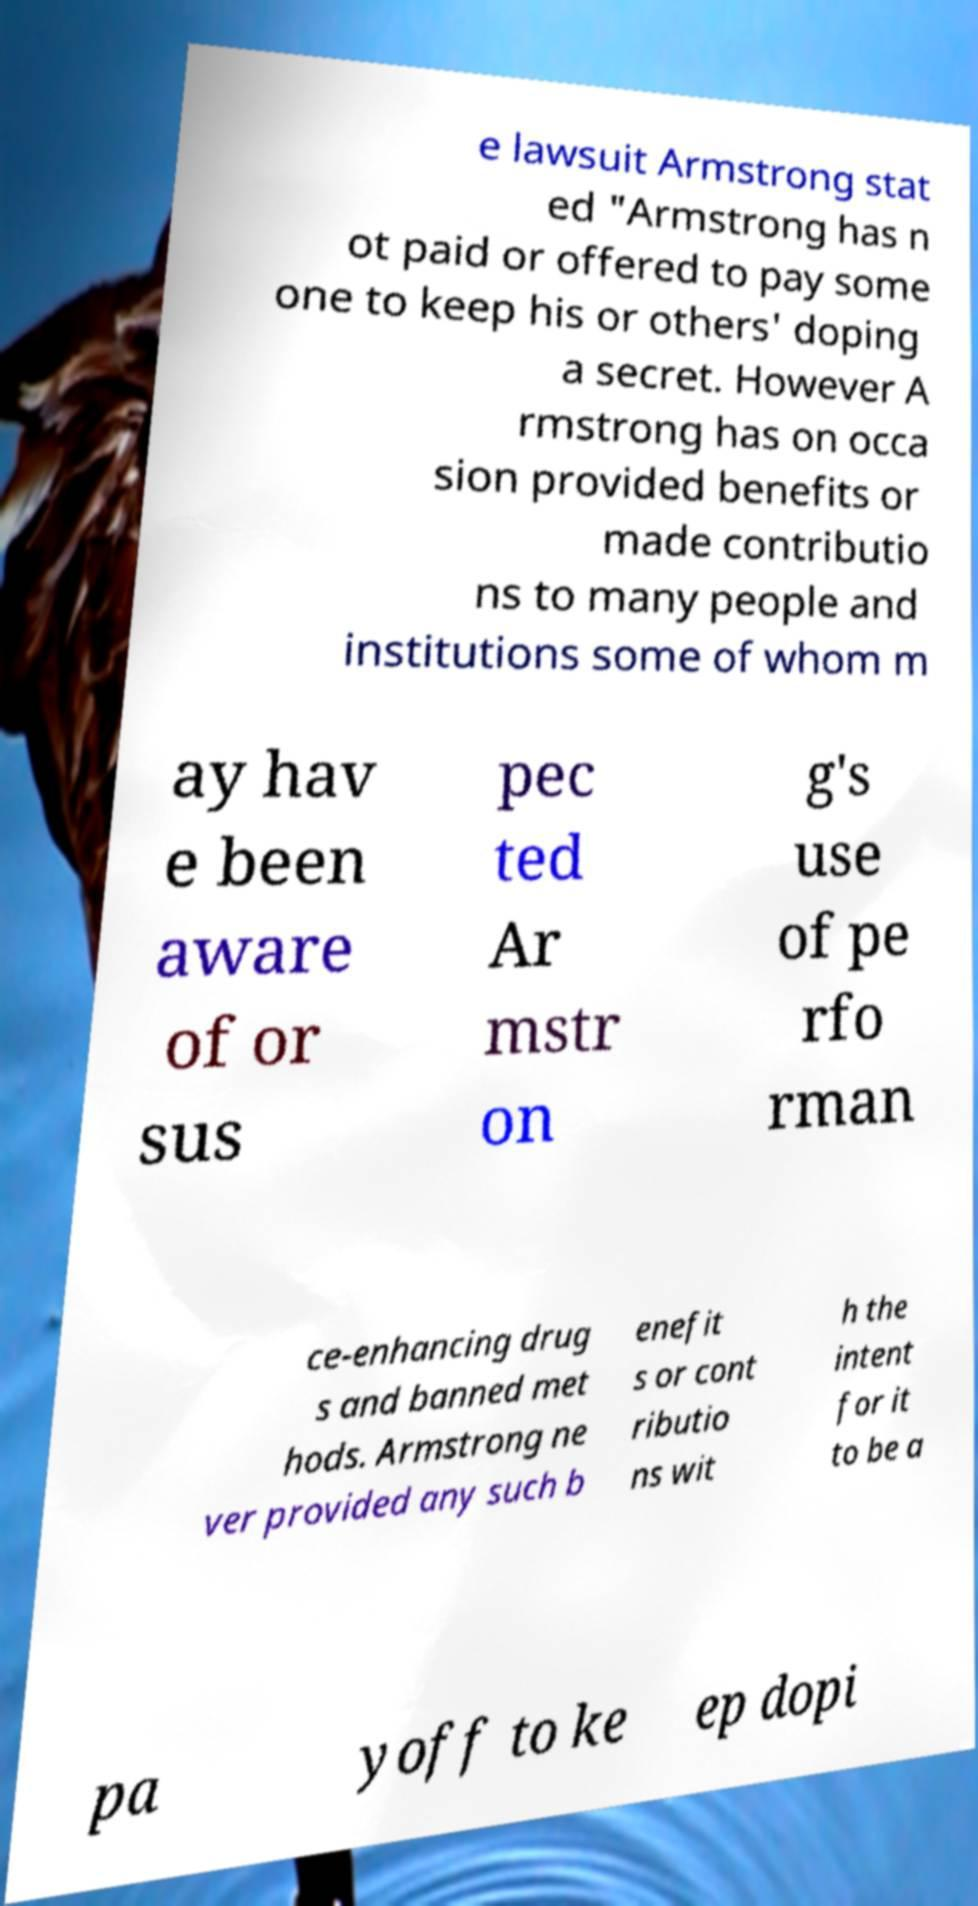Please identify and transcribe the text found in this image. e lawsuit Armstrong stat ed "Armstrong has n ot paid or offered to pay some one to keep his or others' doping a secret. However A rmstrong has on occa sion provided benefits or made contributio ns to many people and institutions some of whom m ay hav e been aware of or sus pec ted Ar mstr on g's use of pe rfo rman ce-enhancing drug s and banned met hods. Armstrong ne ver provided any such b enefit s or cont ributio ns wit h the intent for it to be a pa yoff to ke ep dopi 